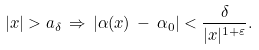Convert formula to latex. <formula><loc_0><loc_0><loc_500><loc_500>| x | > a _ { \delta } \, \Rightarrow \, | \alpha ( x ) \, - \, \alpha _ { 0 } | < \frac { \delta } { | x | ^ { 1 + \varepsilon } } .</formula> 